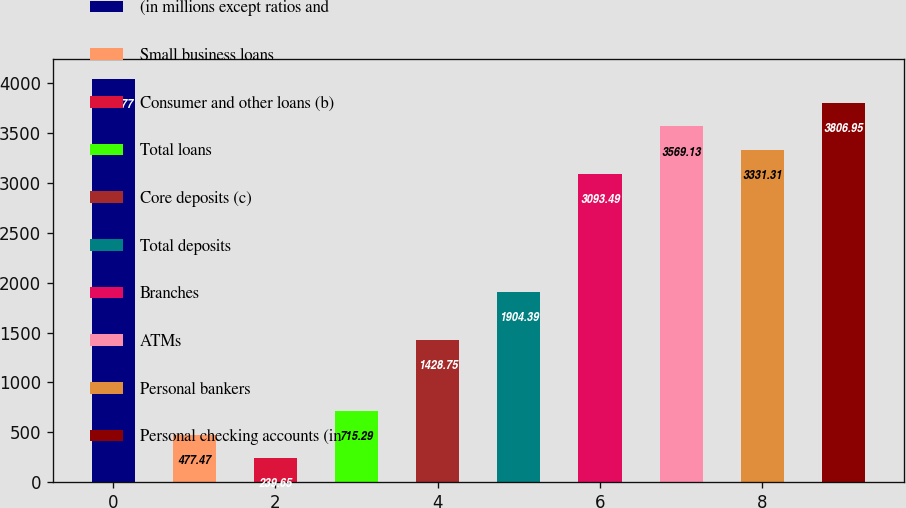Convert chart to OTSL. <chart><loc_0><loc_0><loc_500><loc_500><bar_chart><fcel>(in millions except ratios and<fcel>Small business loans<fcel>Consumer and other loans (b)<fcel>Total loans<fcel>Core deposits (c)<fcel>Total deposits<fcel>Branches<fcel>ATMs<fcel>Personal bankers<fcel>Personal checking accounts (in<nl><fcel>4044.77<fcel>477.47<fcel>239.65<fcel>715.29<fcel>1428.75<fcel>1904.39<fcel>3093.49<fcel>3569.13<fcel>3331.31<fcel>3806.95<nl></chart> 